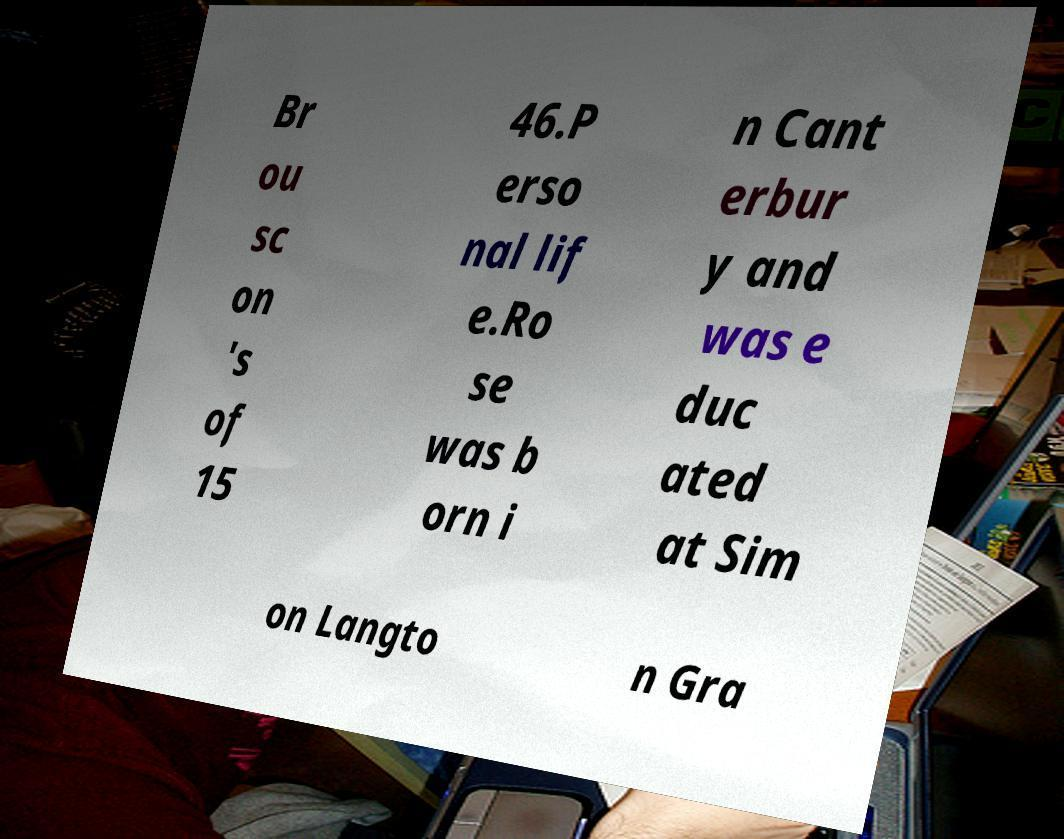What messages or text are displayed in this image? I need them in a readable, typed format. Br ou sc on 's of 15 46.P erso nal lif e.Ro se was b orn i n Cant erbur y and was e duc ated at Sim on Langto n Gra 